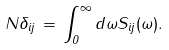Convert formula to latex. <formula><loc_0><loc_0><loc_500><loc_500>N \delta _ { i j } \, = \, \int _ { 0 } ^ { \infty } d \omega S _ { i j } ( \omega ) .</formula> 